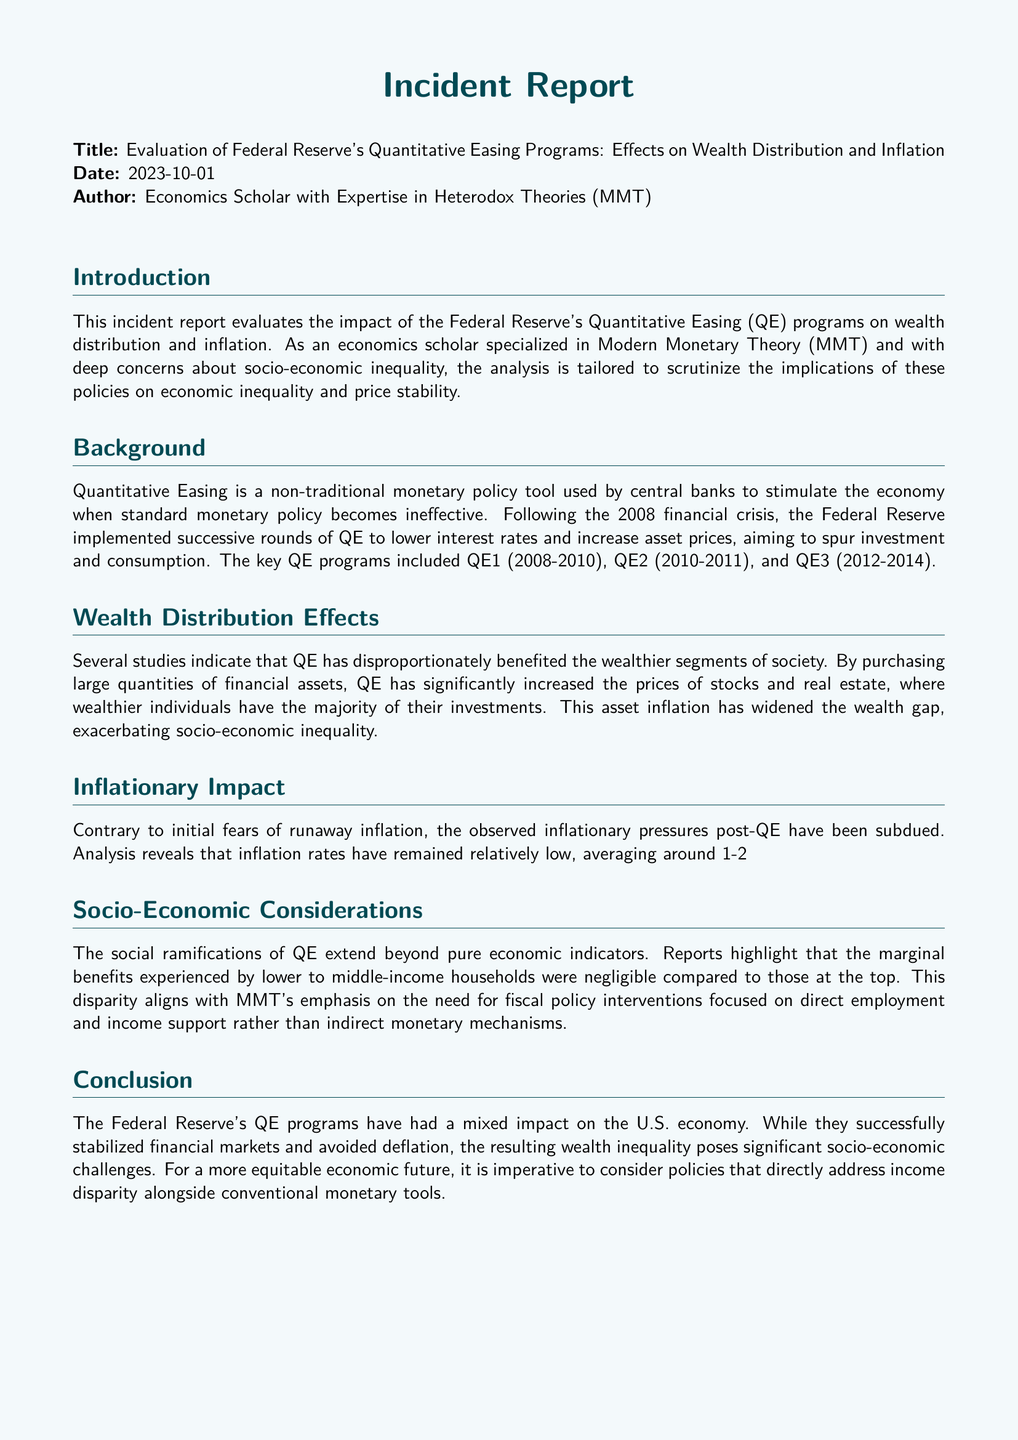What is the title of the report? The title of the report is specified in the document's heading.
Answer: Evaluation of Federal Reserve's Quantitative Easing Programs: Effects on Wealth Distribution and Inflation When was the report published? The date of publication is mentioned right after the title.
Answer: 2023-10-01 Who authored the report? The report states the author's identification in the author section.
Answer: Economics Scholar with Expertise in Heterodox Theories (MMT) What monetary policy tool is evaluated in the report? The document primarily discusses the effectiveness of one specific monetary policy tool.
Answer: Quantitative Easing What is the average inflation rate discussed in the report? The report provides a numerical average related to inflation during the years following the QE programs.
Answer: 1-2% Which income group benefited the most from the QE programs according to the report? The document highlights the beneficiaries of QE programs related to socio-economic status.
Answer: Wealthier segments What was one of the key goals of the Federal Reserve's QE programs? The goals of the QE programs are described within the context of stimulating the economy.
Answer: Lower interest rates What period did QE3 cover? The report mentions specific time frames for each QE program.
Answer: 2012-2014 What does MMT emphasize regarding fiscal policy? The document reflects on the theoretical perspectives of MMT regarding fiscal policy approaches.
Answer: Direct employment and income support 